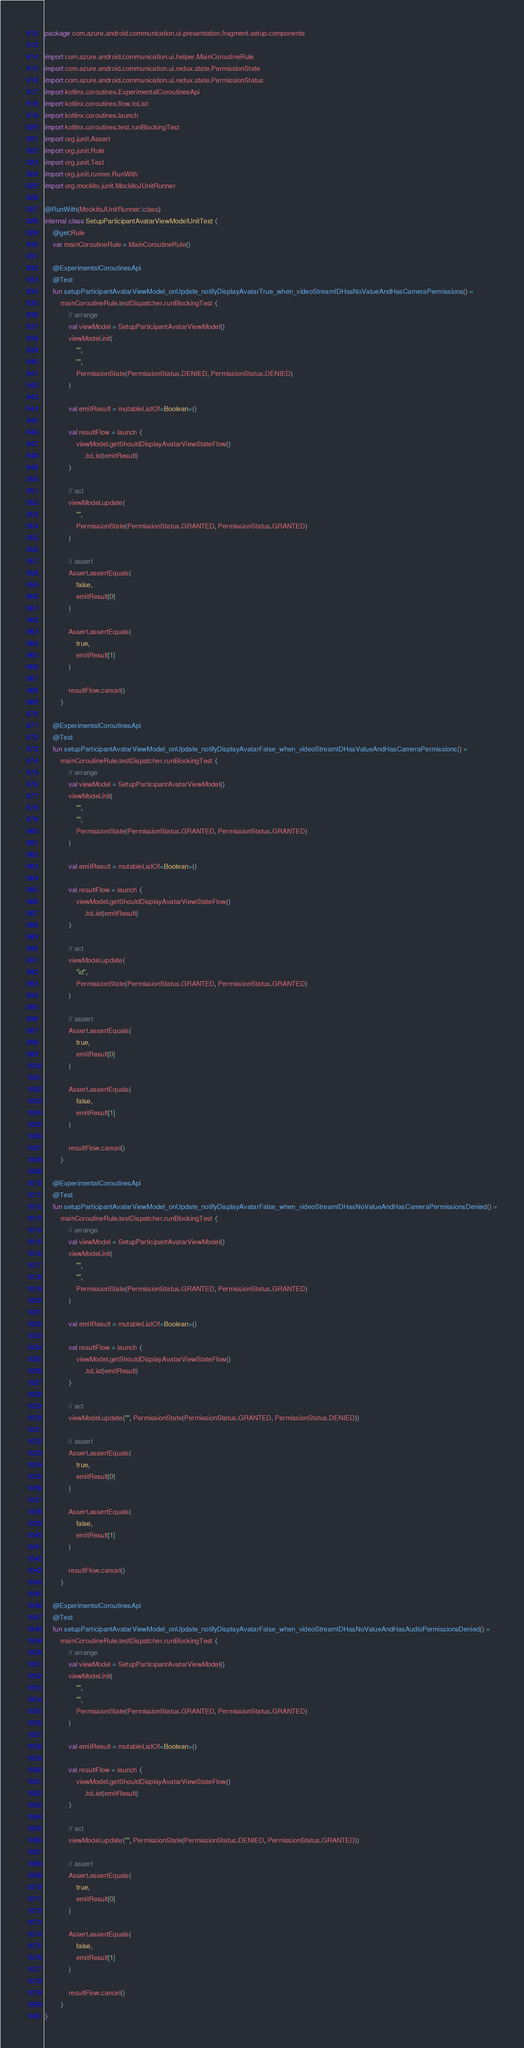Convert code to text. <code><loc_0><loc_0><loc_500><loc_500><_Kotlin_>package com.azure.android.communication.ui.presentation.fragment.setup.components

import com.azure.android.communication.ui.helper.MainCoroutineRule
import com.azure.android.communication.ui.redux.state.PermissionState
import com.azure.android.communication.ui.redux.state.PermissionStatus
import kotlinx.coroutines.ExperimentalCoroutinesApi
import kotlinx.coroutines.flow.toList
import kotlinx.coroutines.launch
import kotlinx.coroutines.test.runBlockingTest
import org.junit.Assert
import org.junit.Rule
import org.junit.Test
import org.junit.runner.RunWith
import org.mockito.junit.MockitoJUnitRunner

@RunWith(MockitoJUnitRunner::class)
internal class SetupParticipantAvatarViewModelUnitTest {
    @get:Rule
    var mainCoroutineRule = MainCoroutineRule()

    @ExperimentalCoroutinesApi
    @Test
    fun setupParticipantAvatarViewModel_onUpdate_notifyDisplayAvatarTrue_when_videoStreamIDHasNoValueAndHasCameraPermissions() =
        mainCoroutineRule.testDispatcher.runBlockingTest {
            // arrange
            val viewModel = SetupParticipantAvatarViewModel()
            viewModel.init(
                "",
                "",
                PermissionState(PermissionStatus.DENIED, PermissionStatus.DENIED)
            )

            val emitResult = mutableListOf<Boolean>()

            val resultFlow = launch {
                viewModel.getShouldDisplayAvatarViewStateFlow()
                    .toList(emitResult)
            }

            // act
            viewModel.update(
                "",
                PermissionState(PermissionStatus.GRANTED, PermissionStatus.GRANTED)
            )

            // assert
            Assert.assertEquals(
                false,
                emitResult[0]
            )

            Assert.assertEquals(
                true,
                emitResult[1]
            )

            resultFlow.cancel()
        }

    @ExperimentalCoroutinesApi
    @Test
    fun setupParticipantAvatarViewModel_onUpdate_notifyDisplayAvatarFalse_when_videoStreamIDHasValueAndHasCameraPermissions() =
        mainCoroutineRule.testDispatcher.runBlockingTest {
            // arrange
            val viewModel = SetupParticipantAvatarViewModel()
            viewModel.init(
                "",
                "",
                PermissionState(PermissionStatus.GRANTED, PermissionStatus.GRANTED)
            )

            val emitResult = mutableListOf<Boolean>()

            val resultFlow = launch {
                viewModel.getShouldDisplayAvatarViewStateFlow()
                    .toList(emitResult)
            }

            // act
            viewModel.update(
                "id",
                PermissionState(PermissionStatus.GRANTED, PermissionStatus.GRANTED)
            )

            // assert
            Assert.assertEquals(
                true,
                emitResult[0]
            )

            Assert.assertEquals(
                false,
                emitResult[1]
            )

            resultFlow.cancel()
        }

    @ExperimentalCoroutinesApi
    @Test
    fun setupParticipantAvatarViewModel_onUpdate_notifyDisplayAvatarFalse_when_videoStreamIDHasNoValueAndHasCameraPermissionsDenied() =
        mainCoroutineRule.testDispatcher.runBlockingTest {
            // arrange
            val viewModel = SetupParticipantAvatarViewModel()
            viewModel.init(
                "",
                "",
                PermissionState(PermissionStatus.GRANTED, PermissionStatus.GRANTED)
            )

            val emitResult = mutableListOf<Boolean>()

            val resultFlow = launch {
                viewModel.getShouldDisplayAvatarViewStateFlow()
                    .toList(emitResult)
            }

            // act
            viewModel.update("", PermissionState(PermissionStatus.GRANTED, PermissionStatus.DENIED))

            // assert
            Assert.assertEquals(
                true,
                emitResult[0]
            )

            Assert.assertEquals(
                false,
                emitResult[1]
            )

            resultFlow.cancel()
        }

    @ExperimentalCoroutinesApi
    @Test
    fun setupParticipantAvatarViewModel_onUpdate_notifyDisplayAvatarFalse_when_videoStreamIDHasNoValueAndHasAudioPermissionsDenied() =
        mainCoroutineRule.testDispatcher.runBlockingTest {
            // arrange
            val viewModel = SetupParticipantAvatarViewModel()
            viewModel.init(
                "",
                "",
                PermissionState(PermissionStatus.GRANTED, PermissionStatus.GRANTED)
            )

            val emitResult = mutableListOf<Boolean>()

            val resultFlow = launch {
                viewModel.getShouldDisplayAvatarViewStateFlow()
                    .toList(emitResult)
            }

            // act
            viewModel.update("", PermissionState(PermissionStatus.DENIED, PermissionStatus.GRANTED))

            // assert
            Assert.assertEquals(
                true,
                emitResult[0]
            )

            Assert.assertEquals(
                false,
                emitResult[1]
            )

            resultFlow.cancel()
        }
}
</code> 